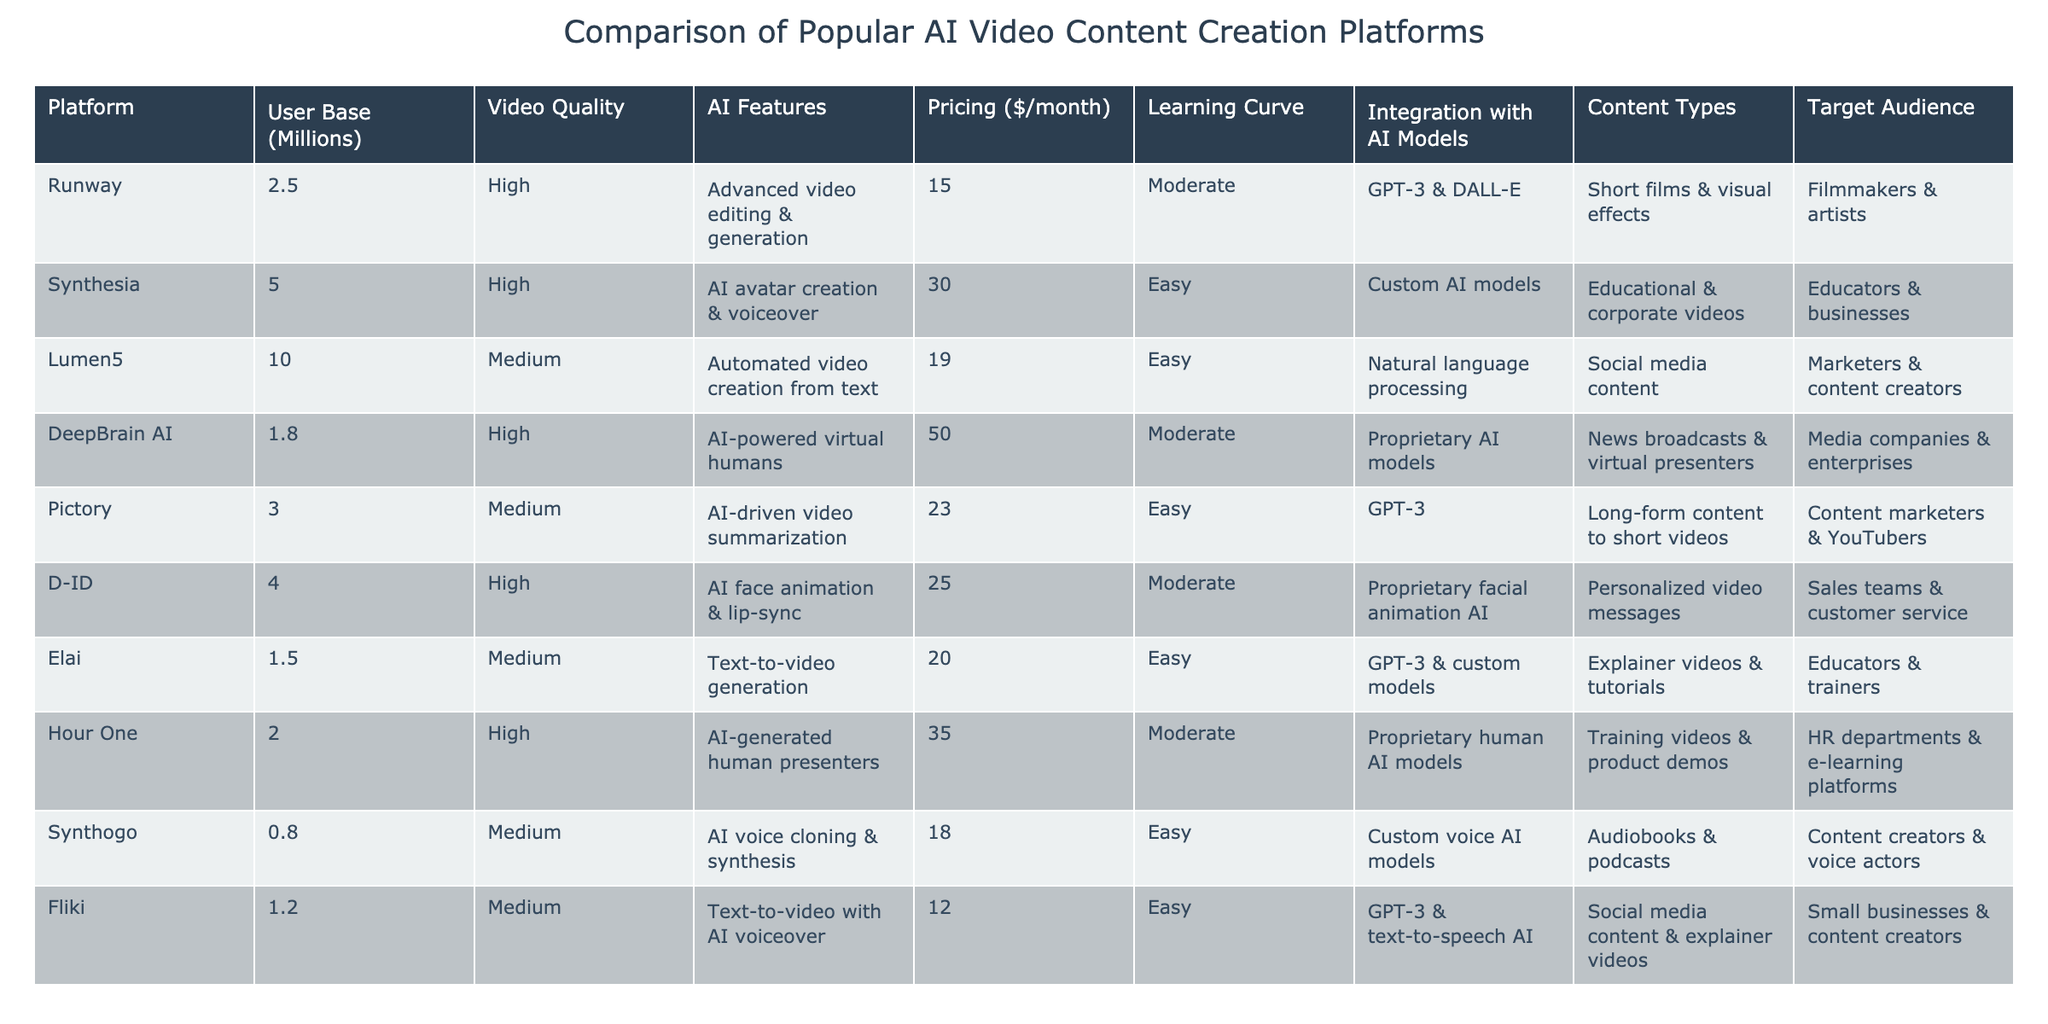What is the user base of Synthesia? From the table, the 'User Base' column shows the value for Synthesia as 5 million users.
Answer: 5 million Which platform has the highest video quality? The 'Video Quality' column indicates that Runway, Synthesia, DeepBrain AI, and D-ID have 'High' quality.
Answer: Runway, Synthesia, DeepBrain AI, and D-ID What is the average pricing of all platforms listed? The sum of the pricing values is (15 + 30 + 19 + 50 + 23 + 25 + 20 + 35 + 18 + 12) =  307, and there are 10 platforms, so the average is 307/10 = 30.7.
Answer: 30.7 Which platform targets filmmakers and artists? By checking the 'Target Audience' column, Runway is the platform that specifically targets filmmakers and artists.
Answer: Runway Is Pictory's user base greater than that of Runway? The user base for Pictory is 3 million and for Runway is 2.5 million; since 3 > 2.5, the statement is true.
Answer: Yes What is the difference in monthly pricing between DeepBrain AI and Synthesia? The pricing for DeepBrain AI is 50, and for Synthesia, it is 30. So, the difference is 50 - 30 = 20.
Answer: 20 Which two platforms are easy to learn and focus on social media content? The platforms that have an 'Easy' learning curve and target social media content are Lumen5 and Fliki.
Answer: Lumen5 and Fliki How many platforms have AI features related to GPT-3? By reviewing the 'AI Features' column, Runway, Pictory, Elai, and Fliki all mention GPT-3 as part of their AI features. This totals to 4 platforms.
Answer: 4 Which platform has the lowest user base and what is it? Synthogo has the lowest user base at 0.8 million.
Answer: 0.8 million Is the integration with AI models for Lumen5 a proprietary system? The 'Integration with AI Models' column lists Lumen5 as using 'Natural language processing', which is not a proprietary system. Therefore, the statement is false.
Answer: No 